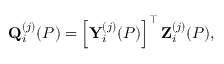Convert formula to latex. <formula><loc_0><loc_0><loc_500><loc_500>Q _ { i } ^ { ( j ) } ( P ) = \left [ Y _ { i } ^ { ( j ) } ( P ) \right ] ^ { \top } Z _ { i } ^ { ( j ) } ( P ) ,</formula> 